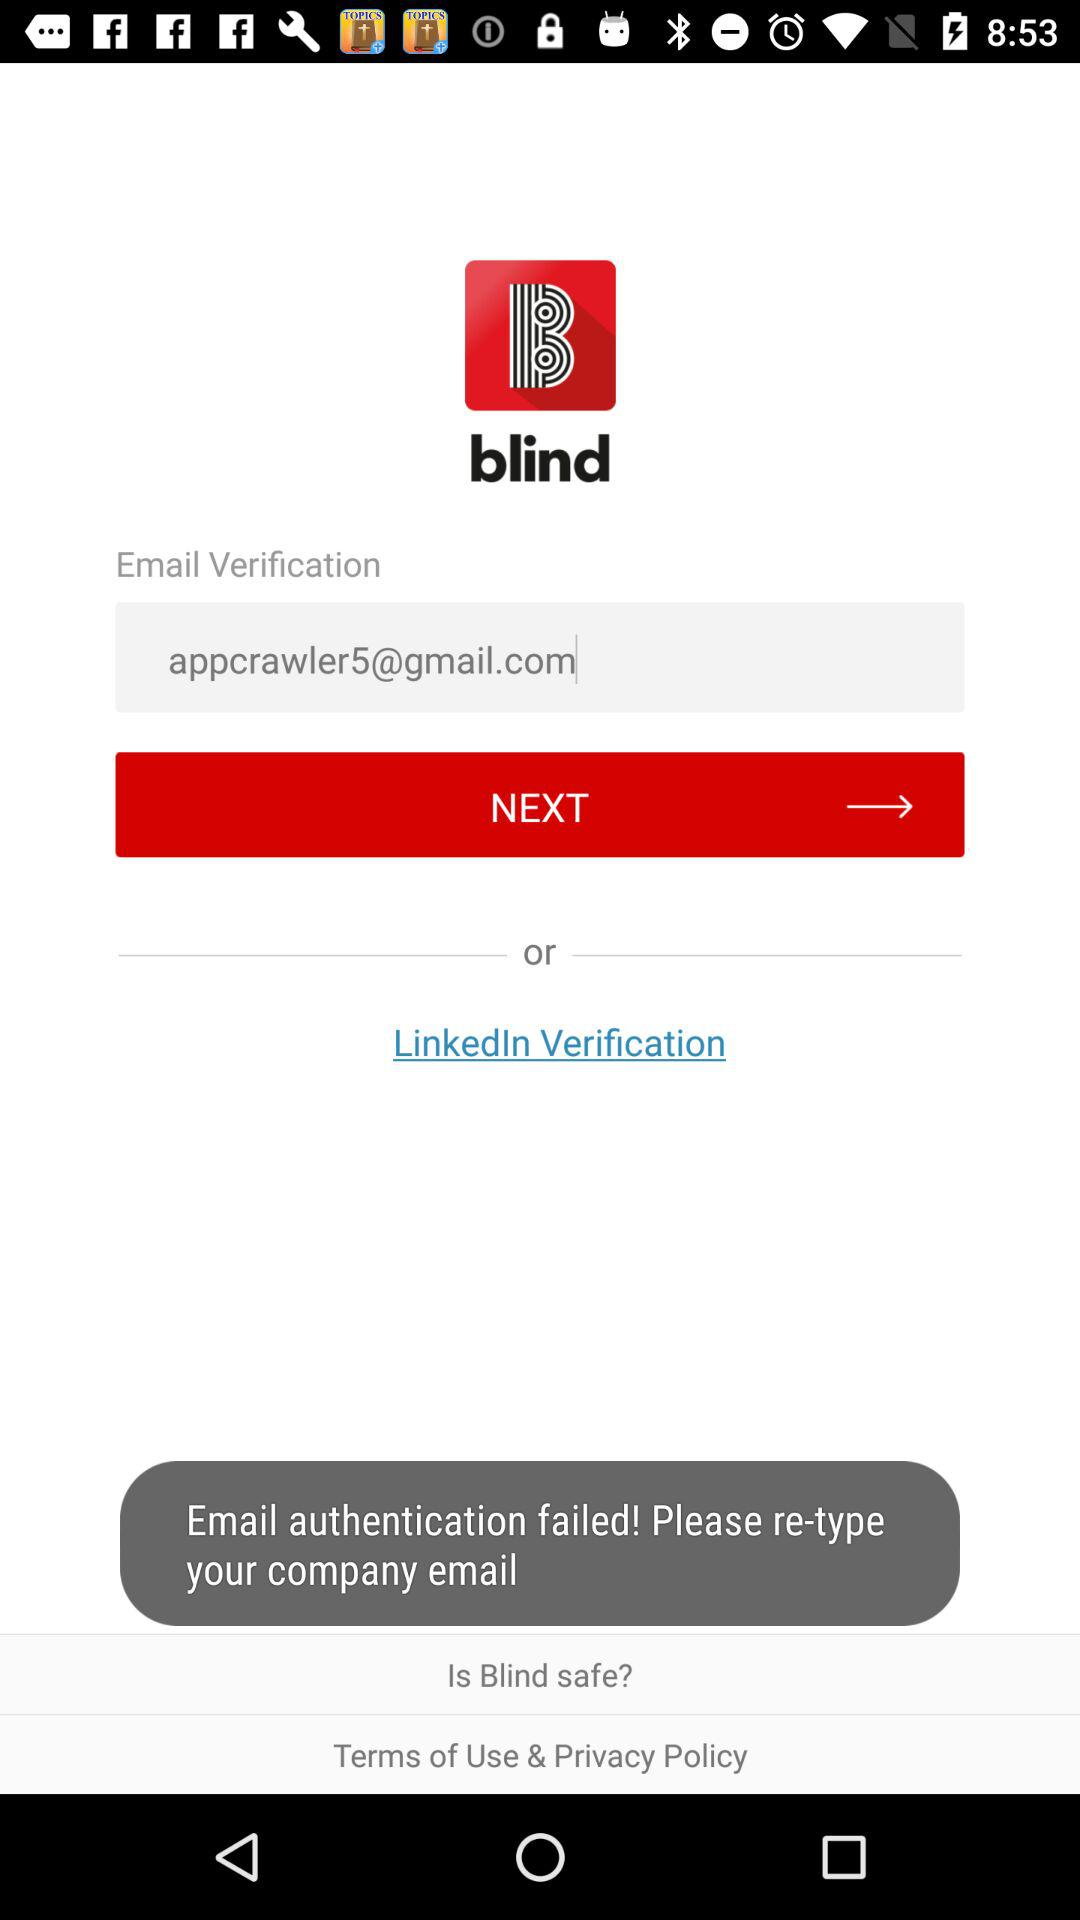What is the application name? The application name is "blind". 